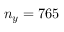<formula> <loc_0><loc_0><loc_500><loc_500>n _ { y } = 7 6 5</formula> 